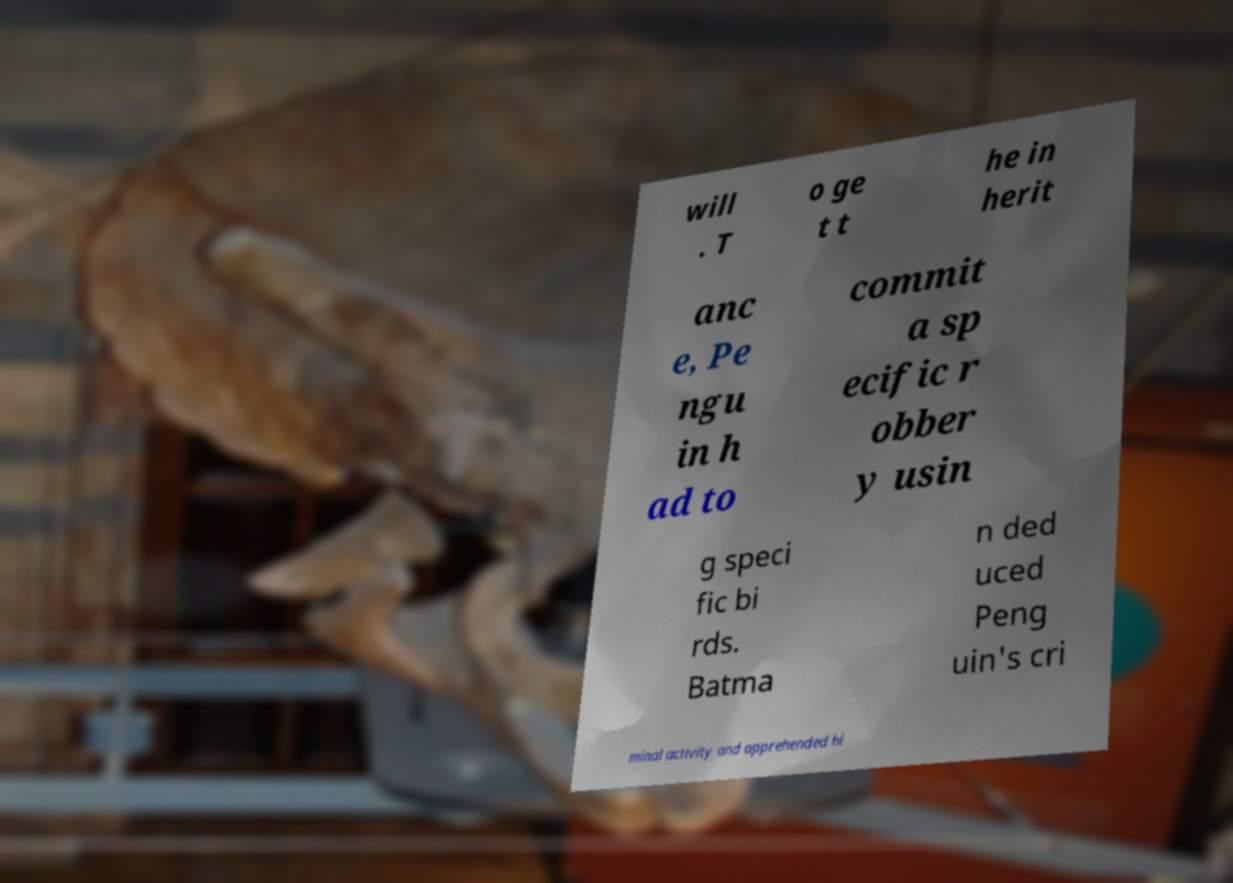There's text embedded in this image that I need extracted. Can you transcribe it verbatim? will . T o ge t t he in herit anc e, Pe ngu in h ad to commit a sp ecific r obber y usin g speci fic bi rds. Batma n ded uced Peng uin's cri minal activity and apprehended hi 